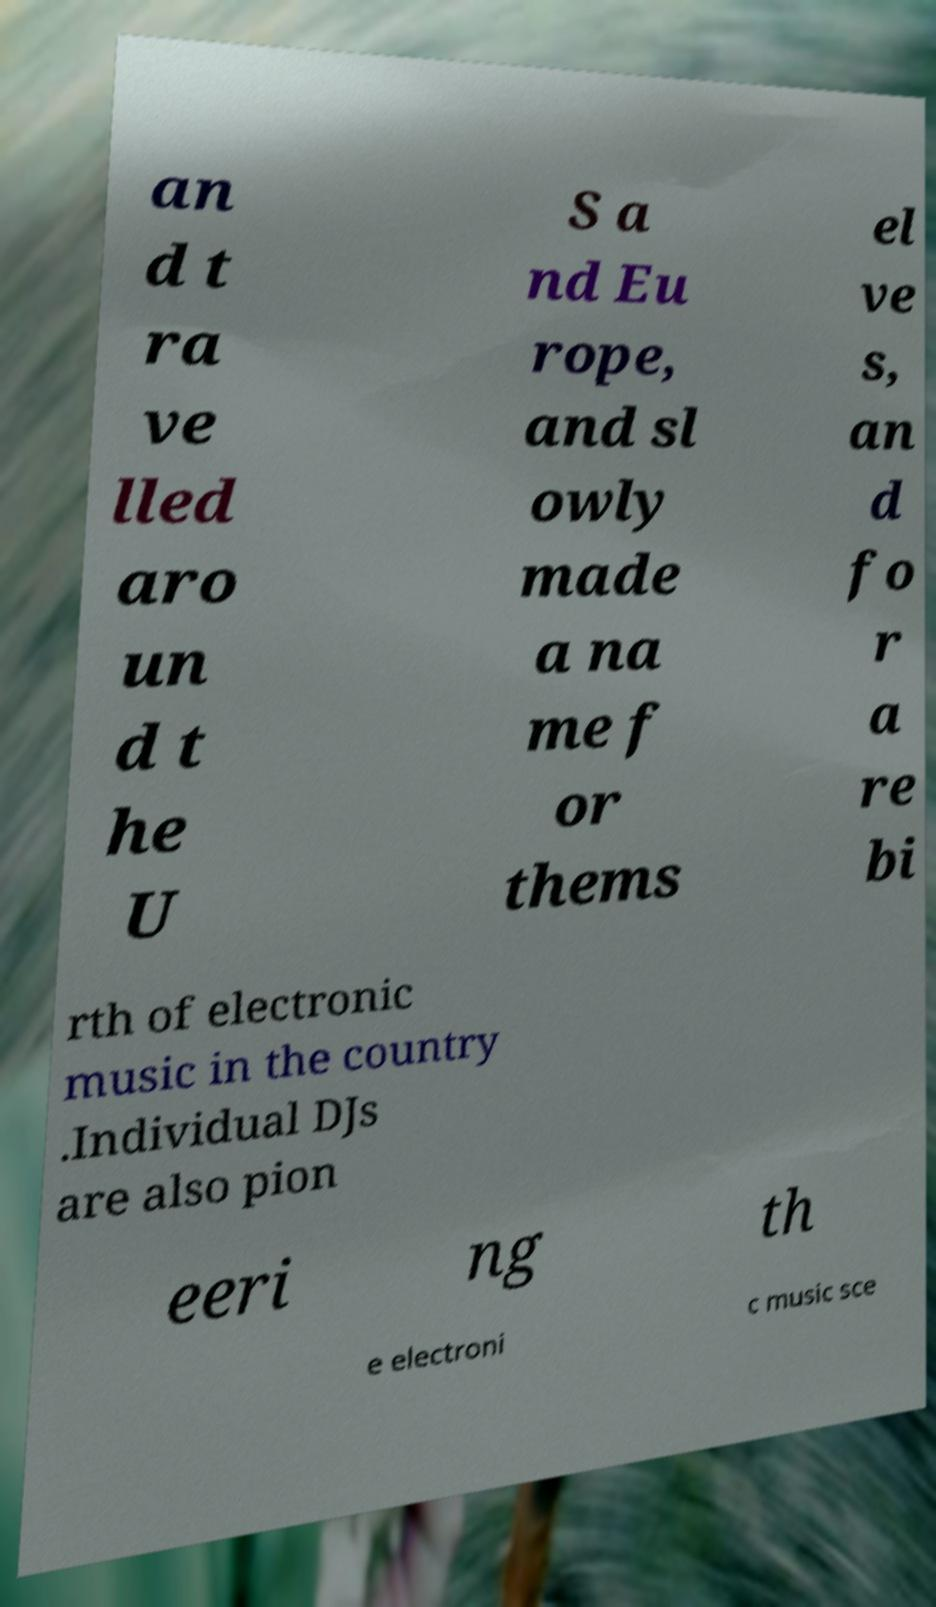Can you read and provide the text displayed in the image?This photo seems to have some interesting text. Can you extract and type it out for me? an d t ra ve lled aro un d t he U S a nd Eu rope, and sl owly made a na me f or thems el ve s, an d fo r a re bi rth of electronic music in the country .Individual DJs are also pion eeri ng th e electroni c music sce 